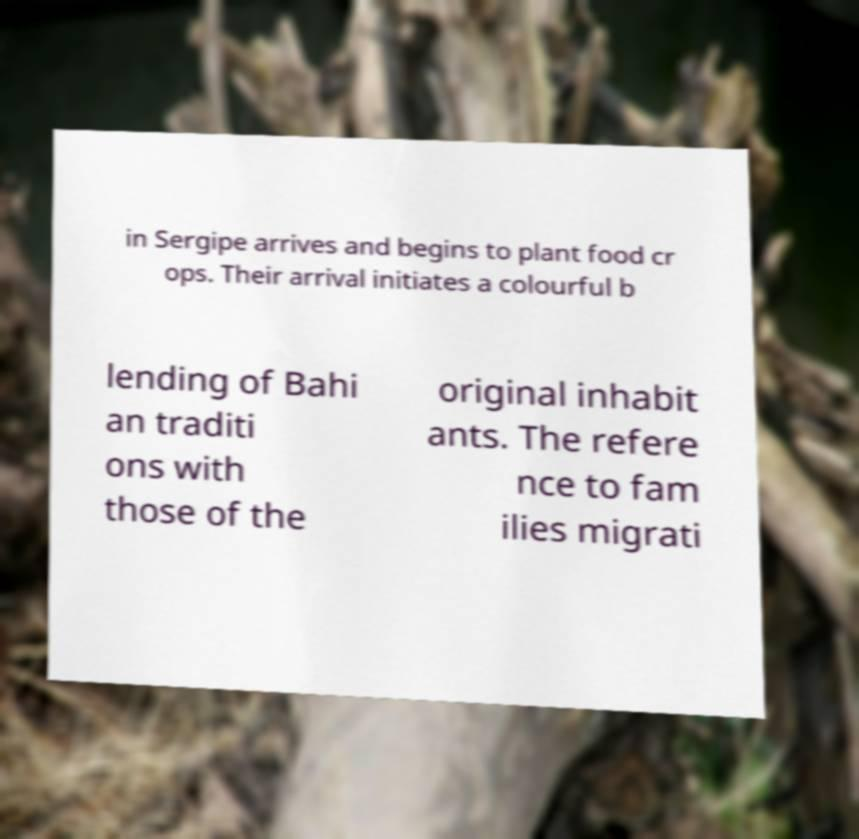Please read and relay the text visible in this image. What does it say? in Sergipe arrives and begins to plant food cr ops. Their arrival initiates a colourful b lending of Bahi an traditi ons with those of the original inhabit ants. The refere nce to fam ilies migrati 